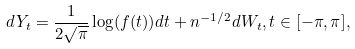Convert formula to latex. <formula><loc_0><loc_0><loc_500><loc_500>d Y _ { t } = \frac { 1 } { 2 \sqrt { \pi } } \log ( f ( t ) ) d t + n ^ { - 1 / 2 } d W _ { t } , t \in [ - \pi , \pi ] ,</formula> 